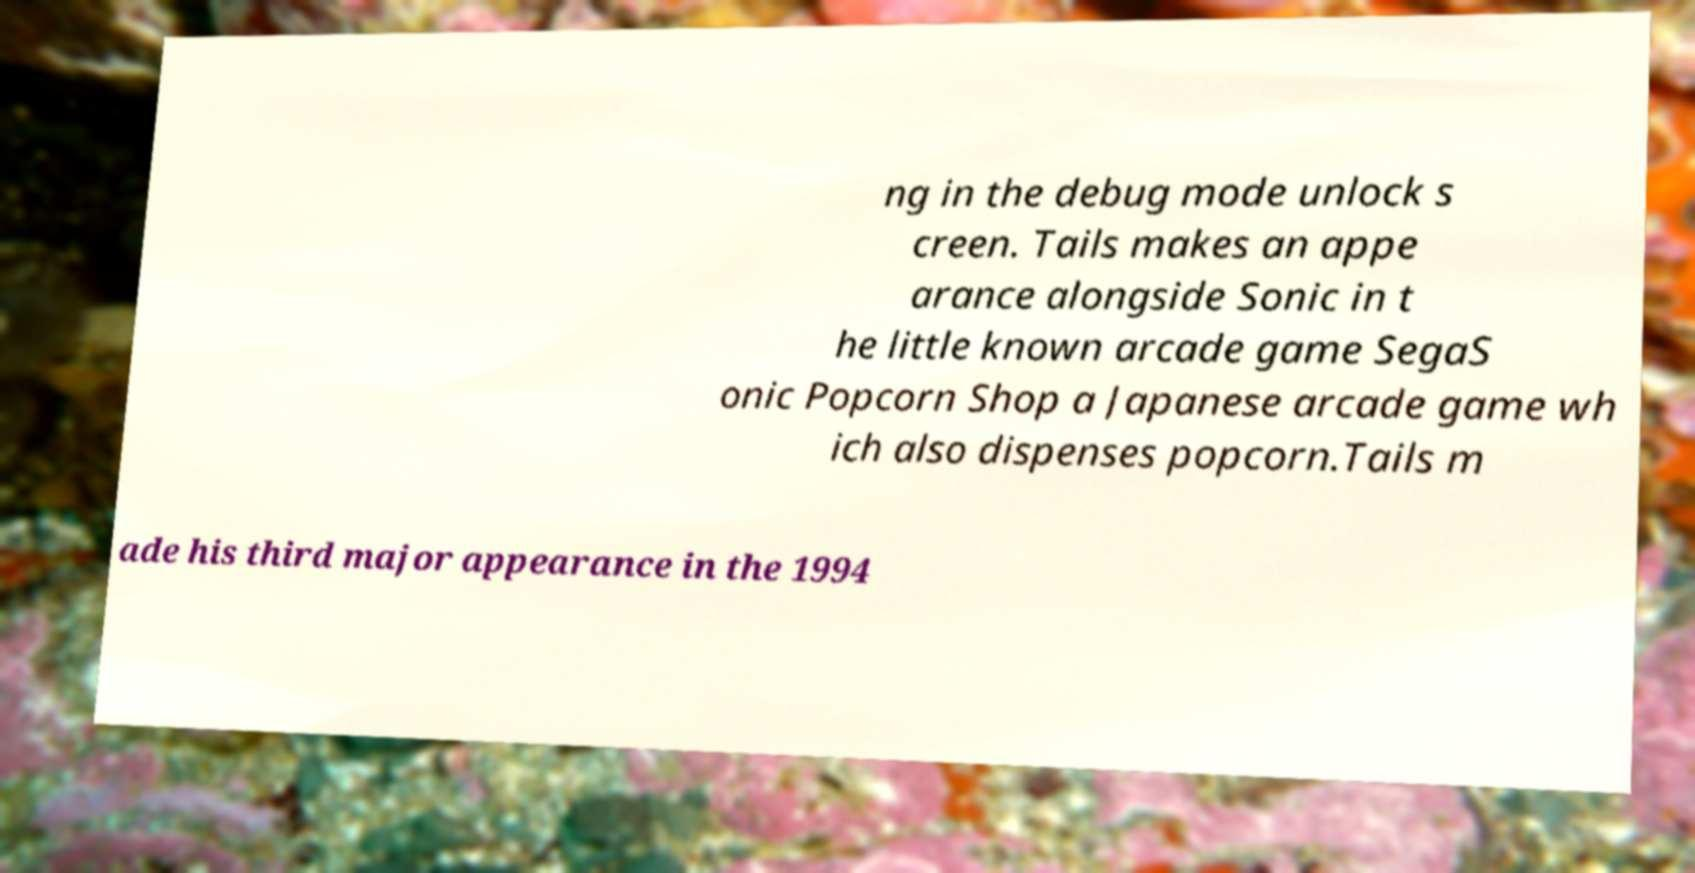Could you extract and type out the text from this image? ng in the debug mode unlock s creen. Tails makes an appe arance alongside Sonic in t he little known arcade game SegaS onic Popcorn Shop a Japanese arcade game wh ich also dispenses popcorn.Tails m ade his third major appearance in the 1994 